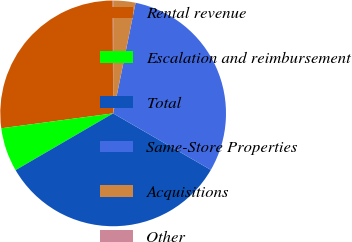Convert chart. <chart><loc_0><loc_0><loc_500><loc_500><pie_chart><fcel>Rental revenue<fcel>Escalation and reimbursement<fcel>Total<fcel>Same-Store Properties<fcel>Acquisitions<fcel>Other<nl><fcel>27.05%<fcel>6.28%<fcel>33.27%<fcel>30.16%<fcel>3.18%<fcel>0.07%<nl></chart> 